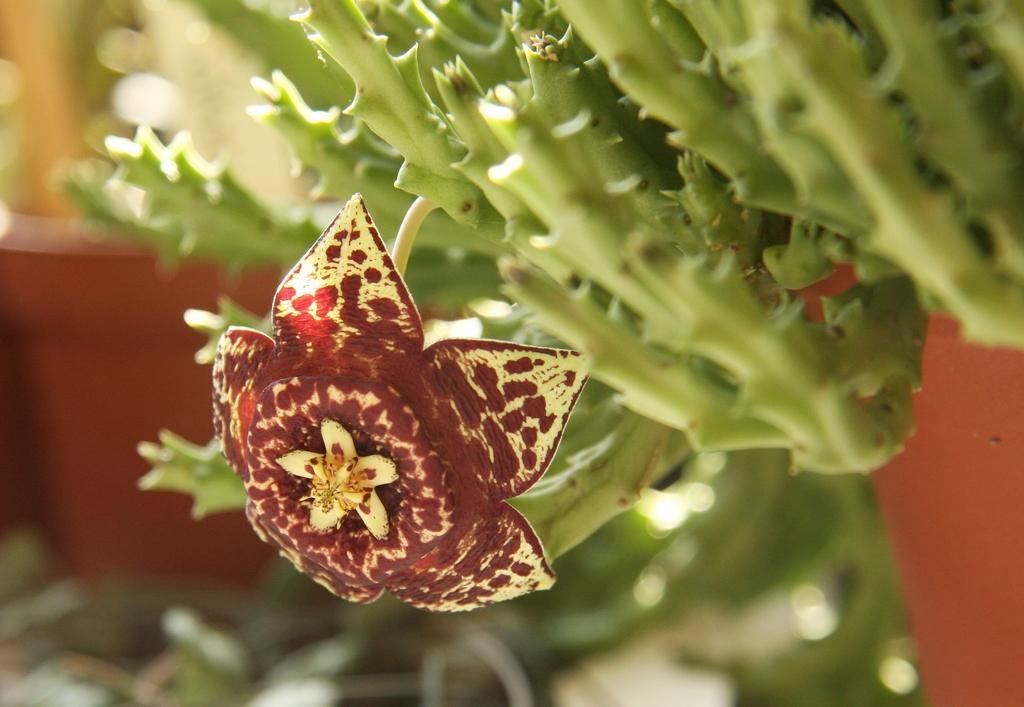How would you summarize this image in a sentence or two? In the center of the image we can see flower to a plant. In the background we can see house plant. 